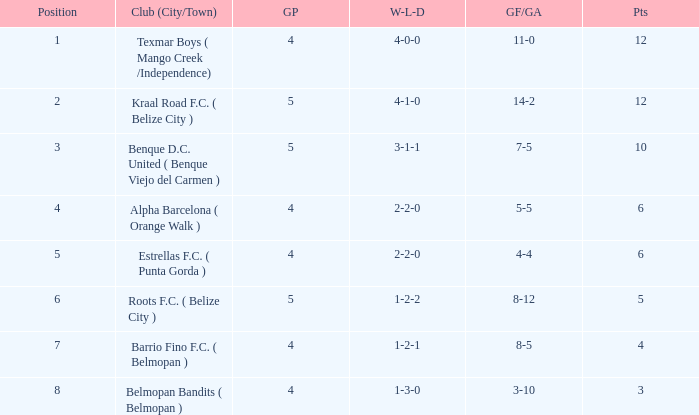With a 3-1-1 w-l-d record, what are the aims for and against? 7-5. 